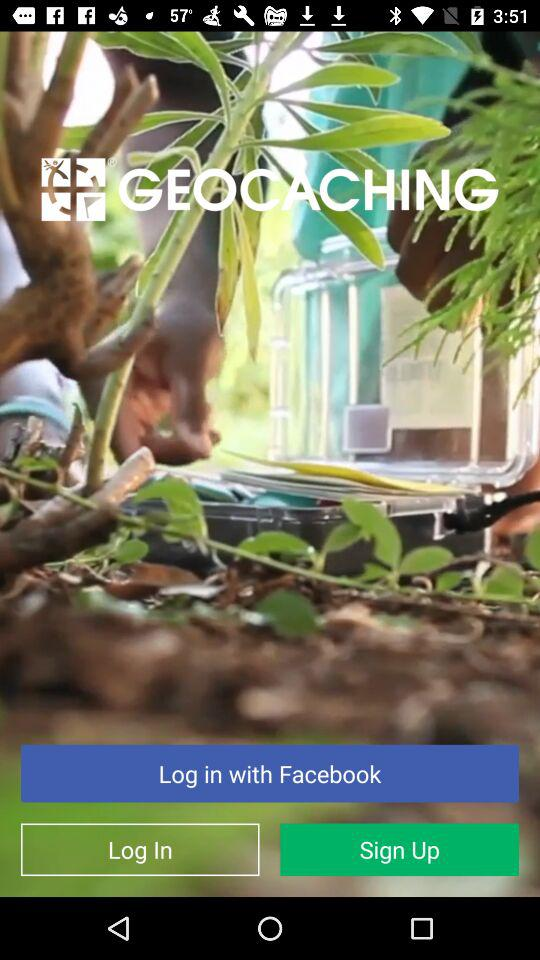What is the application name? The application name is "GEOCACHING". 